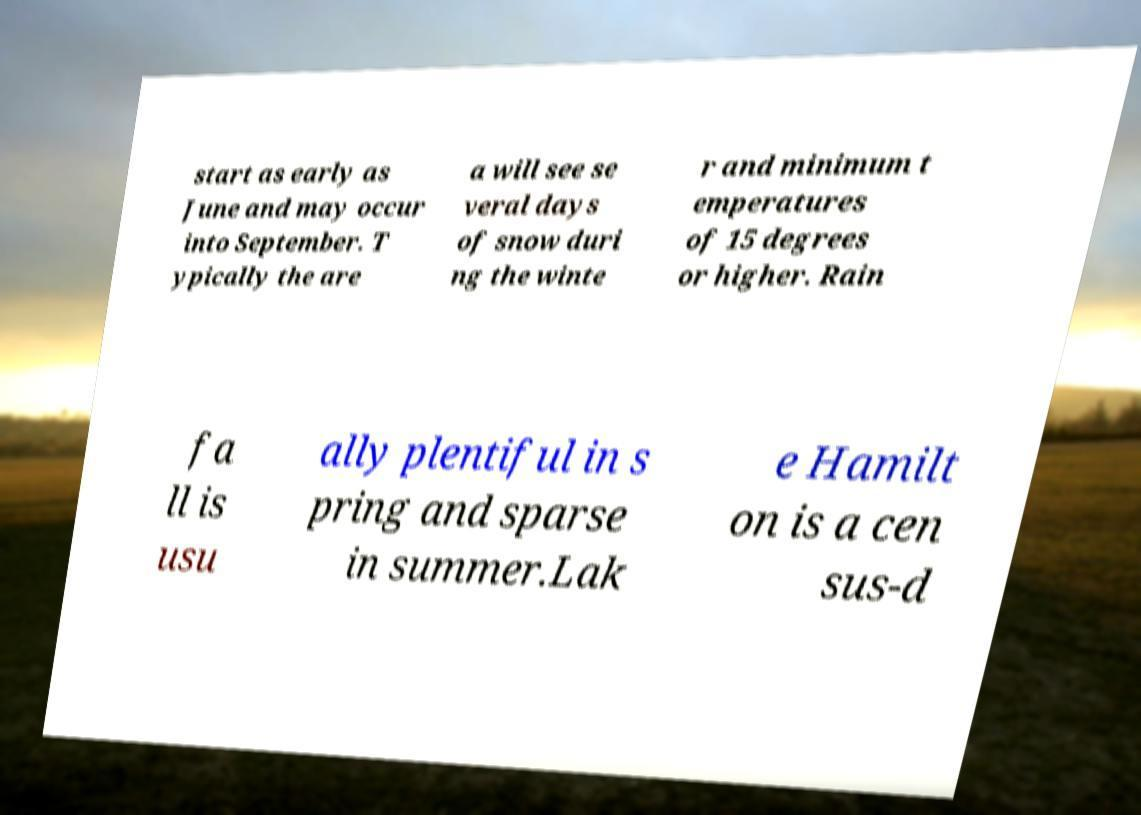What messages or text are displayed in this image? I need them in a readable, typed format. start as early as June and may occur into September. T ypically the are a will see se veral days of snow duri ng the winte r and minimum t emperatures of 15 degrees or higher. Rain fa ll is usu ally plentiful in s pring and sparse in summer.Lak e Hamilt on is a cen sus-d 